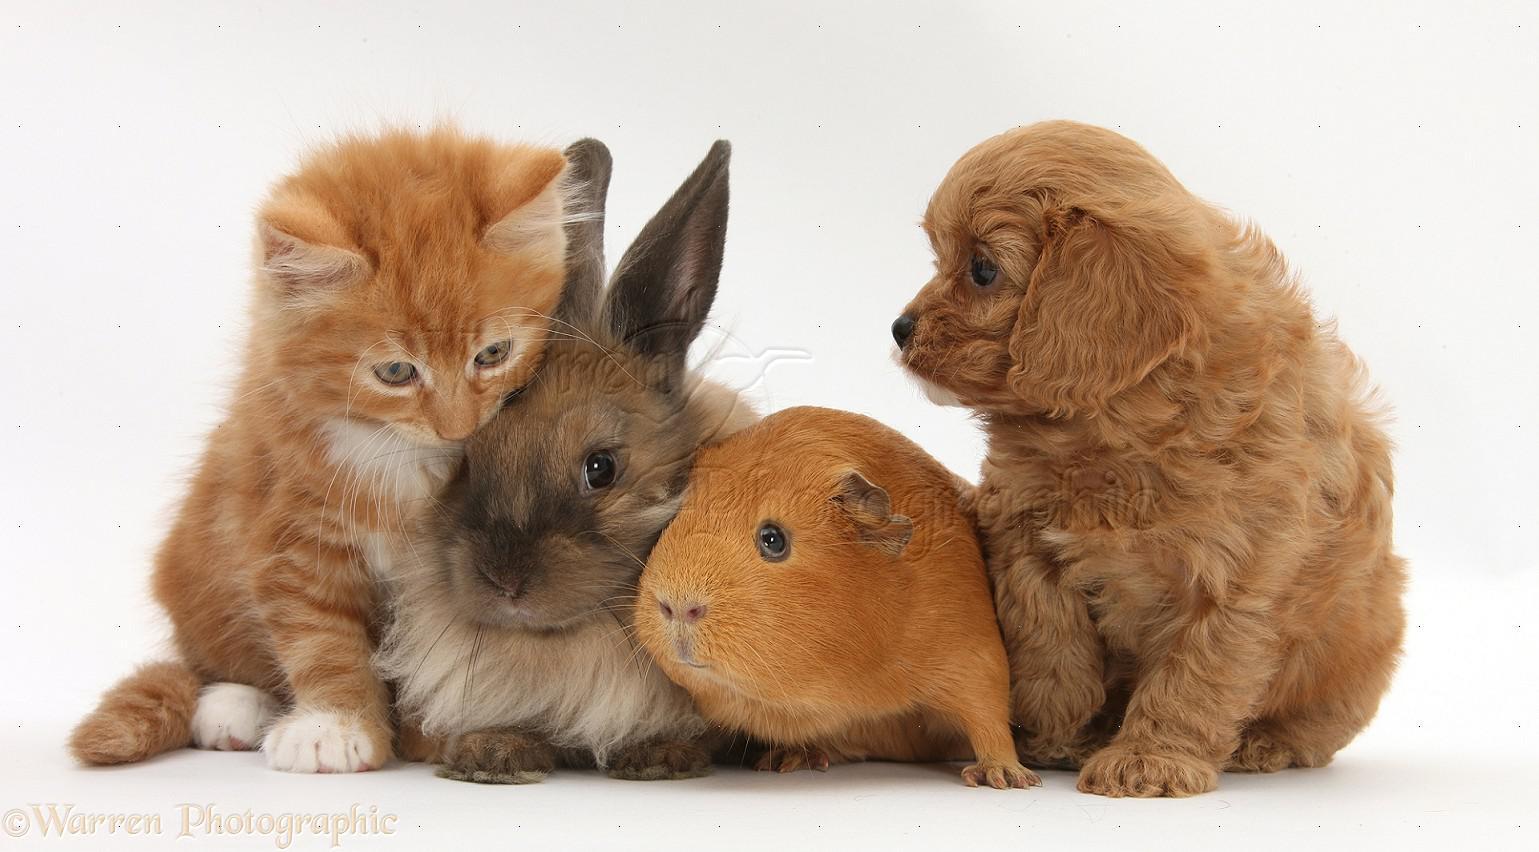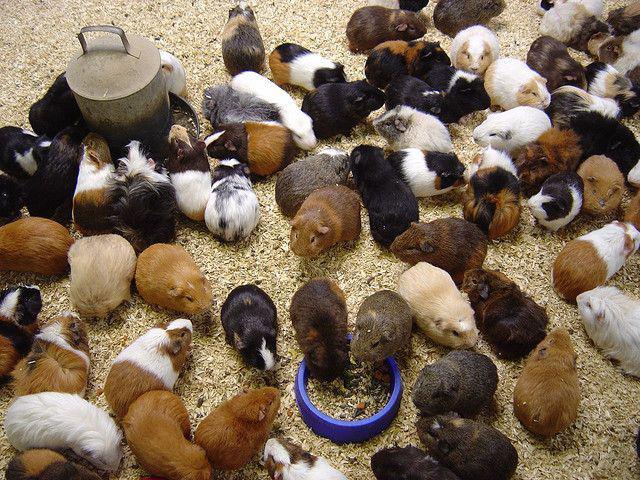The first image is the image on the left, the second image is the image on the right. Analyze the images presented: Is the assertion "An image shows exactly two hamsters side by side." valid? Answer yes or no. No. The first image is the image on the left, the second image is the image on the right. Analyze the images presented: Is the assertion "One image contains only two guinea pigs." valid? Answer yes or no. No. 